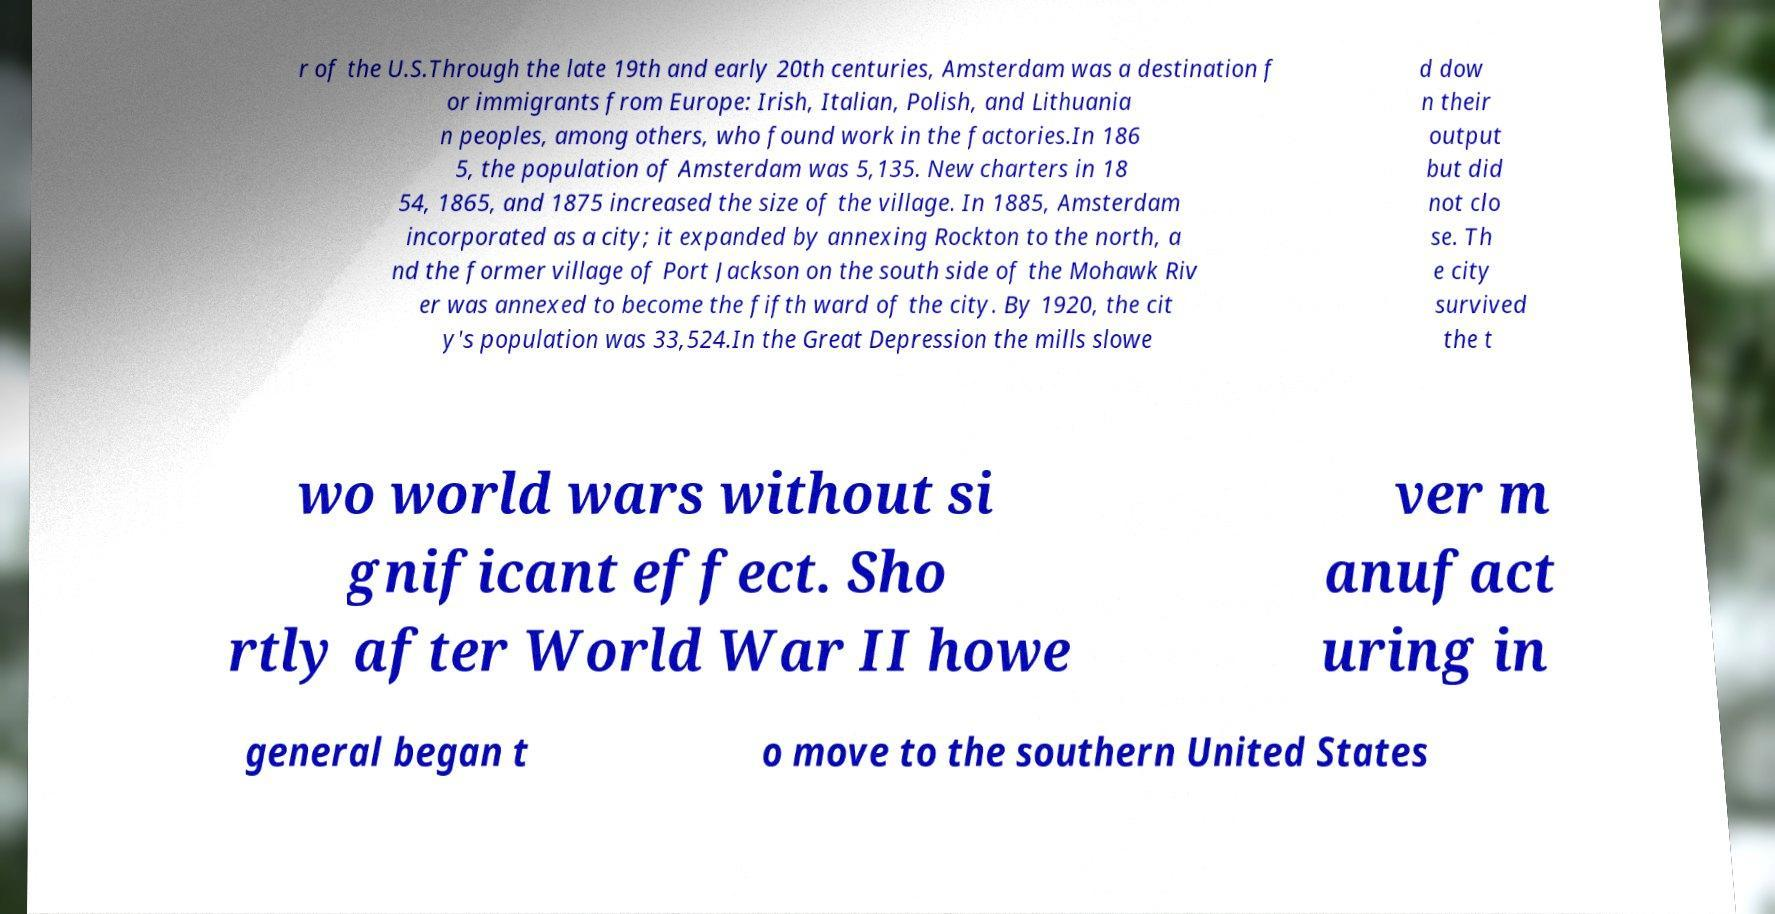Could you assist in decoding the text presented in this image and type it out clearly? r of the U.S.Through the late 19th and early 20th centuries, Amsterdam was a destination f or immigrants from Europe: Irish, Italian, Polish, and Lithuania n peoples, among others, who found work in the factories.In 186 5, the population of Amsterdam was 5,135. New charters in 18 54, 1865, and 1875 increased the size of the village. In 1885, Amsterdam incorporated as a city; it expanded by annexing Rockton to the north, a nd the former village of Port Jackson on the south side of the Mohawk Riv er was annexed to become the fifth ward of the city. By 1920, the cit y's population was 33,524.In the Great Depression the mills slowe d dow n their output but did not clo se. Th e city survived the t wo world wars without si gnificant effect. Sho rtly after World War II howe ver m anufact uring in general began t o move to the southern United States 